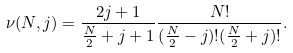Convert formula to latex. <formula><loc_0><loc_0><loc_500><loc_500>\nu ( N , j ) = \frac { 2 j + 1 } { \frac { N } { 2 } + j + 1 } \frac { N ! } { ( \frac { N } { 2 } - j ) ! ( \frac { N } { 2 } + j ) ! } .</formula> 